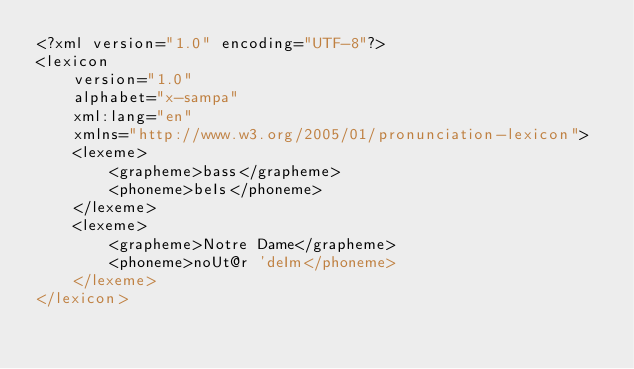Convert code to text. <code><loc_0><loc_0><loc_500><loc_500><_SQL_><?xml version="1.0" encoding="UTF-8"?>
<lexicon
    version="1.0"
    alphabet="x-sampa"
    xml:lang="en"
    xmlns="http://www.w3.org/2005/01/pronunciation-lexicon">
    <lexeme>
        <grapheme>bass</grapheme>
        <phoneme>beIs</phoneme>
    </lexeme>
    <lexeme>
        <grapheme>Notre Dame</grapheme>
        <phoneme>noUt@r 'deIm</phoneme>
    </lexeme>
</lexicon>
</code> 